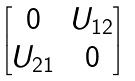<formula> <loc_0><loc_0><loc_500><loc_500>\begin{bmatrix} 0 & U _ { 1 2 } \\ U _ { 2 1 } & 0 \end{bmatrix}</formula> 